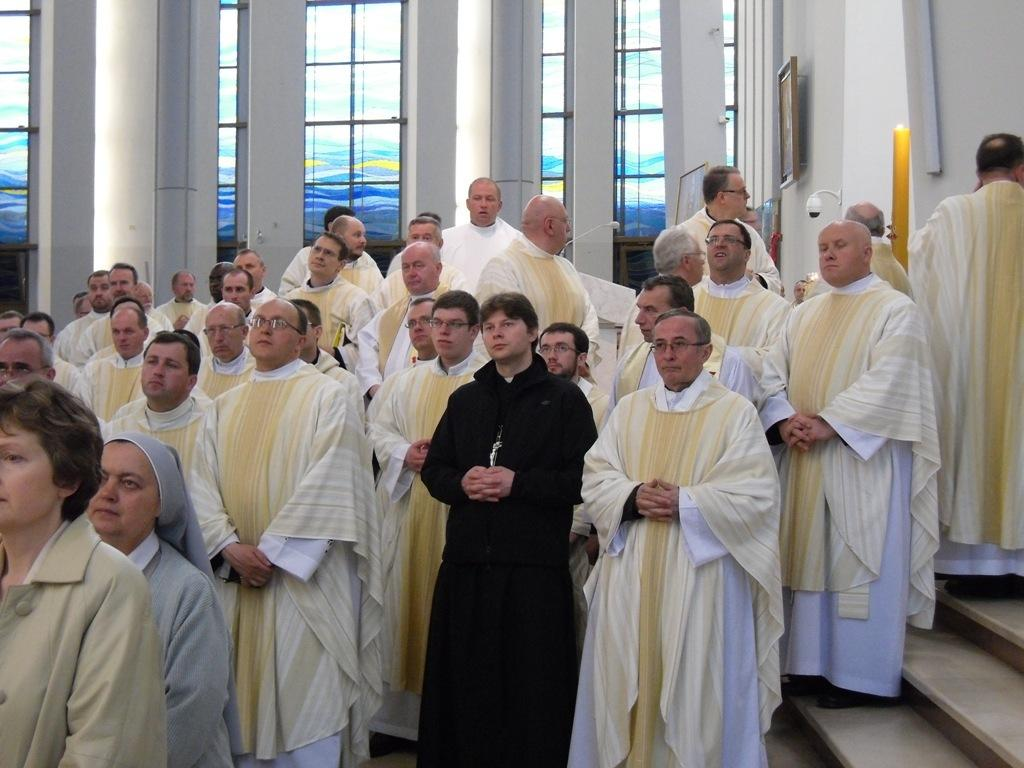Where was the image taken? The image was taken inside a church. What can be observed about the people in the image? There are many people standing in the image. What architectural feature can be seen in the background of the image? There is a glass window in the background of the image. What is another feature visible in the image? Stairs are visible in the image. What grade is the bridge mentioned in the image? There is no bridge mentioned in the image, so it is not possible to determine its grade. 